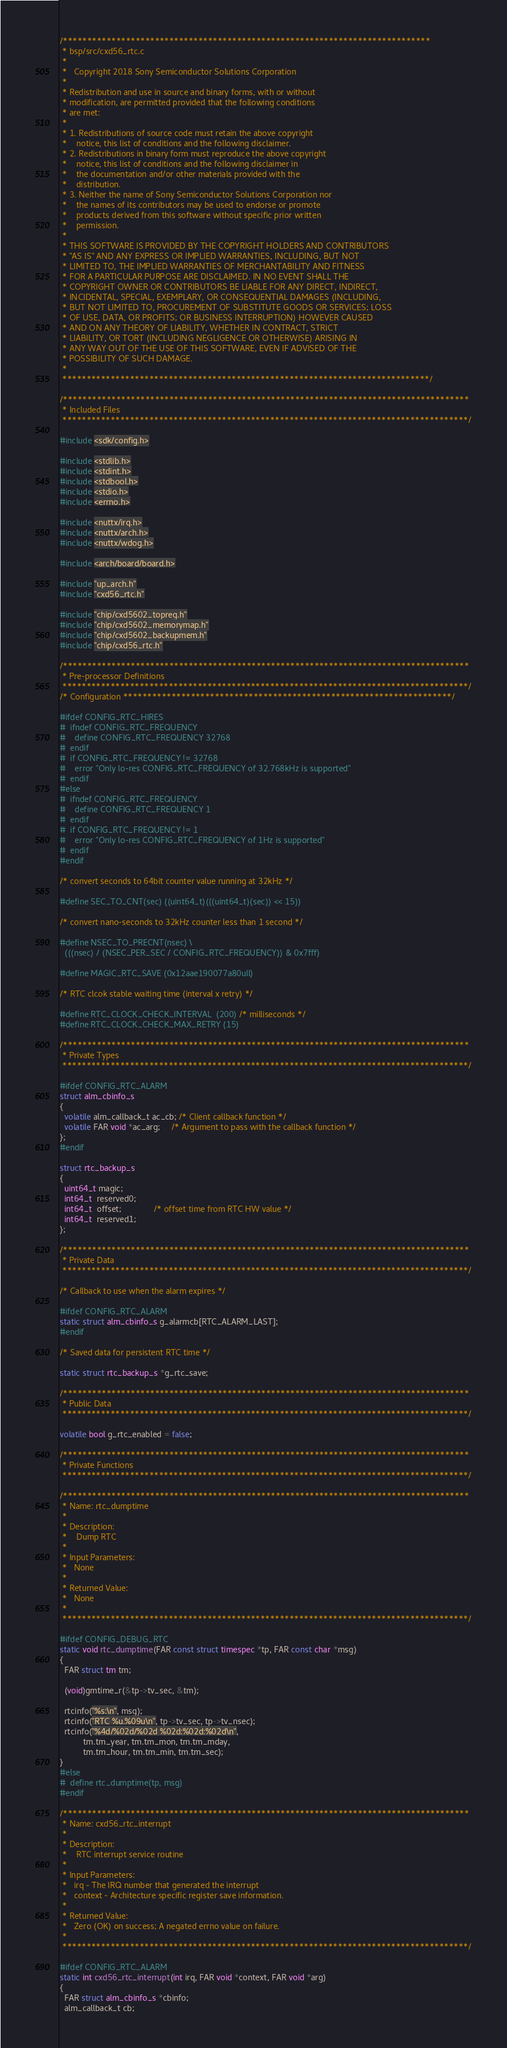Convert code to text. <code><loc_0><loc_0><loc_500><loc_500><_C_>/****************************************************************************
 * bsp/src/cxd56_rtc.c
 *
 *   Copyright 2018 Sony Semiconductor Solutions Corporation
 *
 * Redistribution and use in source and binary forms, with or without
 * modification, are permitted provided that the following conditions
 * are met:
 *
 * 1. Redistributions of source code must retain the above copyright
 *    notice, this list of conditions and the following disclaimer.
 * 2. Redistributions in binary form must reproduce the above copyright
 *    notice, this list of conditions and the following disclaimer in
 *    the documentation and/or other materials provided with the
 *    distribution.
 * 3. Neither the name of Sony Semiconductor Solutions Corporation nor
 *    the names of its contributors may be used to endorse or promote
 *    products derived from this software without specific prior written
 *    permission.
 *
 * THIS SOFTWARE IS PROVIDED BY THE COPYRIGHT HOLDERS AND CONTRIBUTORS
 * "AS IS" AND ANY EXPRESS OR IMPLIED WARRANTIES, INCLUDING, BUT NOT
 * LIMITED TO, THE IMPLIED WARRANTIES OF MERCHANTABILITY AND FITNESS
 * FOR A PARTICULAR PURPOSE ARE DISCLAIMED. IN NO EVENT SHALL THE
 * COPYRIGHT OWNER OR CONTRIBUTORS BE LIABLE FOR ANY DIRECT, INDIRECT,
 * INCIDENTAL, SPECIAL, EXEMPLARY, OR CONSEQUENTIAL DAMAGES (INCLUDING,
 * BUT NOT LIMITED TO, PROCUREMENT OF SUBSTITUTE GOODS OR SERVICES; LOSS
 * OF USE, DATA, OR PROFITS; OR BUSINESS INTERRUPTION) HOWEVER CAUSED
 * AND ON ANY THEORY OF LIABILITY, WHETHER IN CONTRACT, STRICT
 * LIABILITY, OR TORT (INCLUDING NEGLIGENCE OR OTHERWISE) ARISING IN
 * ANY WAY OUT OF THE USE OF THIS SOFTWARE, EVEN IF ADVISED OF THE
 * POSSIBILITY OF SUCH DAMAGE.
 *
 ****************************************************************************/

/************************************************************************************
 * Included Files
 ************************************************************************************/

#include <sdk/config.h>

#include <stdlib.h>
#include <stdint.h>
#include <stdbool.h>
#include <stdio.h>
#include <errno.h>

#include <nuttx/irq.h>
#include <nuttx/arch.h>
#include <nuttx/wdog.h>

#include <arch/board/board.h>

#include "up_arch.h"
#include "cxd56_rtc.h"

#include "chip/cxd5602_topreg.h"
#include "chip/cxd5602_memorymap.h"
#include "chip/cxd5602_backupmem.h"
#include "chip/cxd56_rtc.h"

/************************************************************************************
 * Pre-processor Definitions
 ************************************************************************************/
/* Configuration ********************************************************************/

#ifdef CONFIG_RTC_HIRES
#  ifndef CONFIG_RTC_FREQUENCY
#    define CONFIG_RTC_FREQUENCY 32768
#  endif
#  if CONFIG_RTC_FREQUENCY != 32768
#    error "Only lo-res CONFIG_RTC_FREQUENCY of 32.768kHz is supported"
#  endif
#else
#  ifndef CONFIG_RTC_FREQUENCY
#    define CONFIG_RTC_FREQUENCY 1
#  endif
#  if CONFIG_RTC_FREQUENCY != 1
#    error "Only lo-res CONFIG_RTC_FREQUENCY of 1Hz is supported"
#  endif
#endif

/* convert seconds to 64bit counter value running at 32kHz */

#define SEC_TO_CNT(sec) ((uint64_t)(((uint64_t)(sec)) << 15))

/* convert nano-seconds to 32kHz counter less than 1 second */

#define NSEC_TO_PRECNT(nsec) \
  (((nsec) / (NSEC_PER_SEC / CONFIG_RTC_FREQUENCY)) & 0x7fff)

#define MAGIC_RTC_SAVE (0x12aae190077a80ull)

/* RTC clcok stable waiting time (interval x retry) */

#define RTC_CLOCK_CHECK_INTERVAL  (200) /* milliseconds */
#define RTC_CLOCK_CHECK_MAX_RETRY (15)

/************************************************************************************
 * Private Types
 ************************************************************************************/

#ifdef CONFIG_RTC_ALARM
struct alm_cbinfo_s
{
  volatile alm_callback_t ac_cb; /* Client callback function */
  volatile FAR void *ac_arg;     /* Argument to pass with the callback function */
};
#endif

struct rtc_backup_s
{
  uint64_t magic;
  int64_t  reserved0;
  int64_t  offset;              /* offset time from RTC HW value */
  int64_t  reserved1;
};

/************************************************************************************
 * Private Data
 ************************************************************************************/

/* Callback to use when the alarm expires */

#ifdef CONFIG_RTC_ALARM
static struct alm_cbinfo_s g_alarmcb[RTC_ALARM_LAST];
#endif

/* Saved data for persistent RTC time */

static struct rtc_backup_s *g_rtc_save;

/************************************************************************************
 * Public Data
 ************************************************************************************/

volatile bool g_rtc_enabled = false;

/************************************************************************************
 * Private Functions
 ************************************************************************************/

/************************************************************************************
 * Name: rtc_dumptime
 *
 * Description:
 *    Dump RTC
 *
 * Input Parameters:
 *   None
 *
 * Returned Value:
 *   None
 *
 ************************************************************************************/

#ifdef CONFIG_DEBUG_RTC
static void rtc_dumptime(FAR const struct timespec *tp, FAR const char *msg)
{
  FAR struct tm tm;

  (void)gmtime_r(&tp->tv_sec, &tm);

  rtcinfo("%s:\n", msg);
  rtcinfo("RTC %u.%09u\n", tp->tv_sec, tp->tv_nsec);
  rtcinfo("%4d/%02d/%02d %02d:%02d:%02d\n",
          tm.tm_year, tm.tm_mon, tm.tm_mday,
          tm.tm_hour, tm.tm_min, tm.tm_sec);
}
#else
#  define rtc_dumptime(tp, msg)
#endif

/************************************************************************************
 * Name: cxd56_rtc_interrupt
 *
 * Description:
 *    RTC interrupt service routine
 *
 * Input Parameters:
 *   irq - The IRQ number that generated the interrupt
 *   context - Architecture specific register save information.
 *
 * Returned Value:
 *   Zero (OK) on success; A negated errno value on failure.
 *
 ************************************************************************************/

#ifdef CONFIG_RTC_ALARM
static int cxd56_rtc_interrupt(int irq, FAR void *context, FAR void *arg)
{
  FAR struct alm_cbinfo_s *cbinfo;
  alm_callback_t cb;</code> 